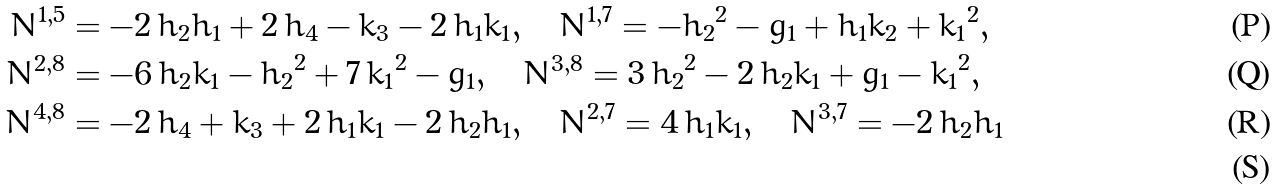<formula> <loc_0><loc_0><loc_500><loc_500>N ^ { 1 , 5 } & = - 2 \, h _ { 2 } h _ { 1 } + 2 \, h _ { 4 } - k _ { 3 } - 2 \, h _ { 1 } k _ { 1 } , \quad N ^ { 1 , 7 } = - { h _ { 2 } } ^ { 2 } - g _ { 1 } + h _ { 1 } k _ { 2 } + { k _ { 1 } } ^ { 2 } , \\ N ^ { 2 , 8 } & = - 6 \, h _ { 2 } k _ { 1 } - { h _ { 2 } } ^ { 2 } + 7 \, { k _ { 1 } } ^ { 2 } - g _ { 1 } , \quad N ^ { 3 , 8 } = 3 \, { h _ { 2 } } ^ { 2 } - 2 \, h _ { 2 } k _ { 1 } + g _ { 1 } - { k _ { 1 } } ^ { 2 } , \\ N ^ { 4 , 8 } & = - 2 \, h _ { 4 } + k _ { 3 } + 2 \, h _ { 1 } k _ { 1 } - 2 \, h _ { 2 } h _ { 1 } , \quad N ^ { 2 , 7 } = 4 \, h _ { 1 } k _ { 1 } , \quad N ^ { 3 , 7 } = - 2 \, h _ { 2 } h _ { 1 } \\</formula> 